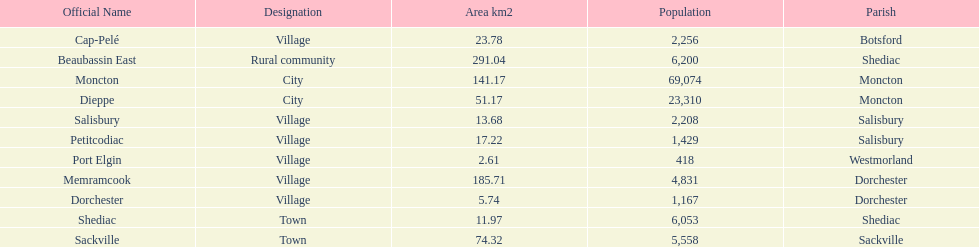Which municipality has the most number of people who reside in it? Moncton. 